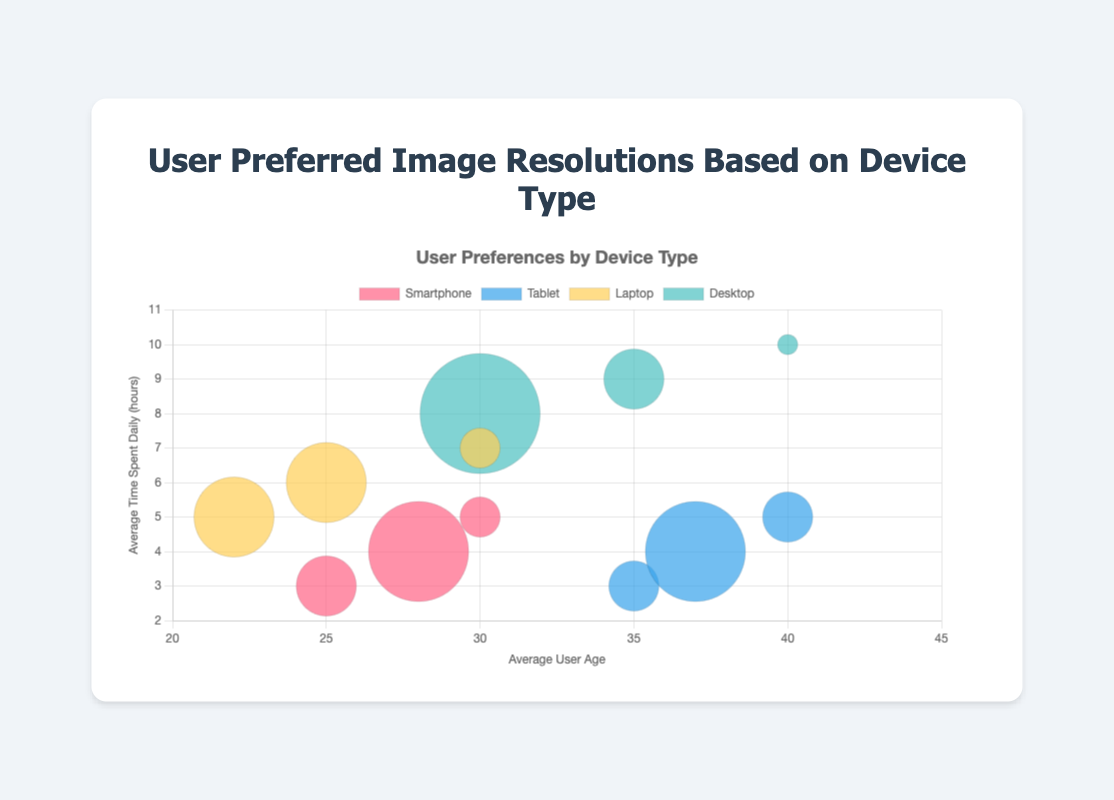What is the most preferred image resolution for Smartphones? The largest bubble in the Smartphone category represents the highest user preference percentage. In this case, the largest bubble corresponds to a resolution of 1080x1920 with 50% user preference.
Answer: 1080x1920 What is the average time spent daily by users who prefer 1920x1080 resolution on Desktops? Look for the Desktop category with the 1920x1080 resolution. The associated average time spent daily is represented by the y-axis value, which is 8 hours.
Answer: 8 hours Which device type has the widest age range among users? To determine the widest age range, look at the x-axis values for each device type. Desktops have an age range from 30 to 40 years. Tablets also have a range from 35 to 40 years. Therefore, Desktops have the same age range as Tablets.
Answer: Desktops and Tablets Compare the user preference percentage for 2560x1440 resolution between Laptops and Desktops. Which has the higher preference? Check the bubble sizes for 2560x1440 resolution in both categories. The Desktop has a bubble representing 30%, which is larger than the Laptop's bubble representing 20%.
Answer: Desktops What is the most common average user age for Laptops? The most common average user age is indicated by the x-axis values with larger bubbles. Both 1366x768 and 1920x1080 resolutions have an average user age of 25 with the largest bubbles.
Answer: 25 years How does the average time spent daily by Smartphone users change with increasing resolution preference? Evaluate the y-axis values of the Smartphone category. For 720x1280, the time spent is 3 hours; for 1080x1920, it's 4 hours; and for 1440x2560, it's 5 hours. The average time spent increases as the resolution increases.
Answer: Increases Which device type and resolution have the smallest user preference percentage? Identify the smallest bubbles across all device types. The smallest bubble corresponds to Desktops with 3840x2160 resolution and 10% user preference.
Answer: Desktops with 3840x2160 resolution Is there any resolution that is similarly preferred by users across more than one device type? Look for bubbles of similar size across different device types. The resolution 1920x1080 is preferred by both Laptops and Desktops equally, each with 40% and 60% respectively.
Answer: No pair with similar sizes What is the relationship between average user age and average time spent daily across device types? Examine the x and y axis values. Generally, as the average user age increases, the average time spent daily also tends to increase across all device types.
Answer: Positive correlation 